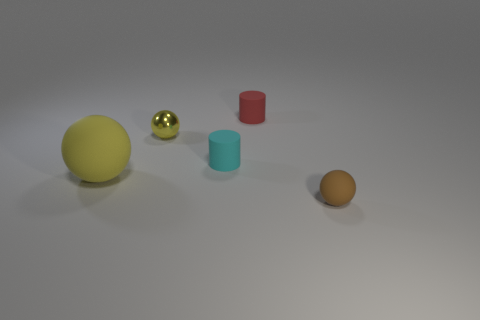Add 4 large yellow spheres. How many objects exist? 9 Subtract all spheres. How many objects are left? 2 Add 2 large yellow matte balls. How many large yellow matte balls are left? 3 Add 2 brown balls. How many brown balls exist? 3 Subtract 0 purple cylinders. How many objects are left? 5 Subtract all purple rubber spheres. Subtract all small shiny spheres. How many objects are left? 4 